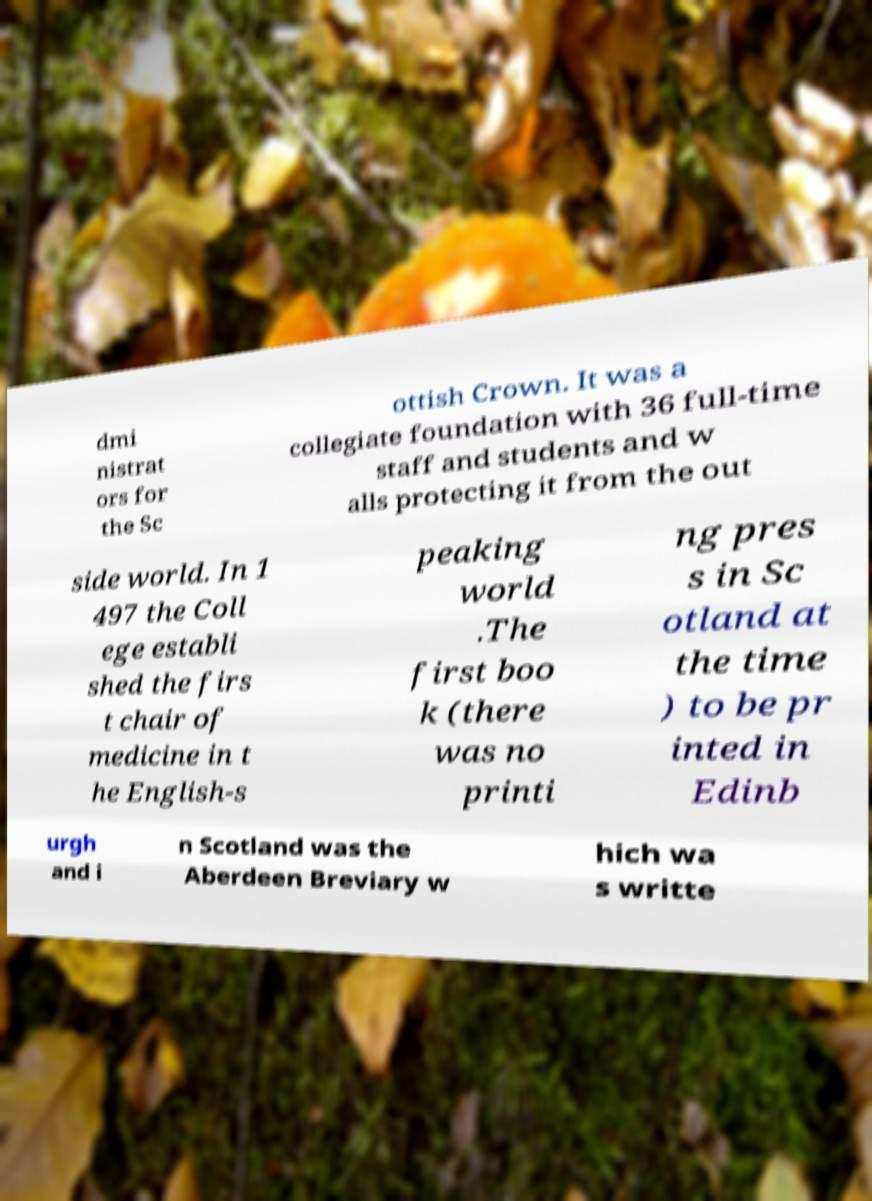Could you extract and type out the text from this image? dmi nistrat ors for the Sc ottish Crown. It was a collegiate foundation with 36 full-time staff and students and w alls protecting it from the out side world. In 1 497 the Coll ege establi shed the firs t chair of medicine in t he English-s peaking world .The first boo k (there was no printi ng pres s in Sc otland at the time ) to be pr inted in Edinb urgh and i n Scotland was the Aberdeen Breviary w hich wa s writte 